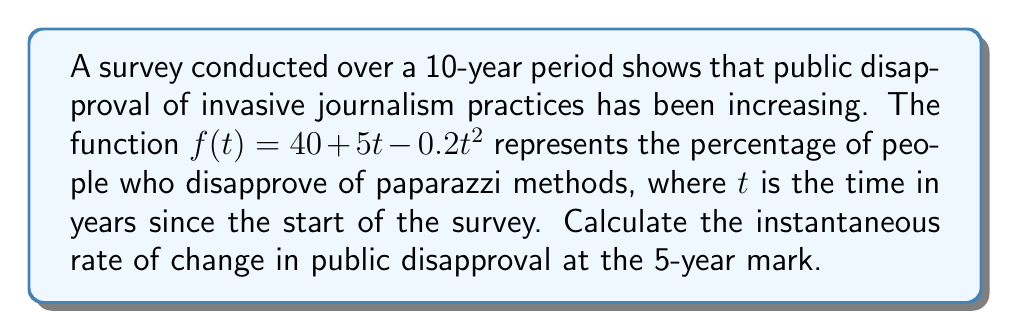Show me your answer to this math problem. To find the instantaneous rate of change at a specific point, we need to calculate the derivative of the function and evaluate it at the given point.

1. The given function is $f(t) = 40 + 5t - 0.2t^2$

2. To find the derivative, we apply the power rule and constant rule:
   $$f'(t) = 5 - 0.4t$$

3. We want to find the rate of change at the 5-year mark, so we evaluate $f'(5)$:
   $$f'(5) = 5 - 0.4(5) = 5 - 2 = 3$$

4. Interpret the result:
   The instantaneous rate of change at $t=5$ is 3 percentage points per year. This means that at the 5-year mark, public disapproval of invasive journalism was increasing at a rate of 3% per year.

5. Note on the function's behavior:
   The negative coefficient of $t^2$ indicates that the rate of increase in disapproval is slowing down over time, which could suggest that public opinion is approaching a saturation point.
Answer: The instantaneous rate of change in public disapproval of invasive journalism at the 5-year mark is 3 percentage points per year. 